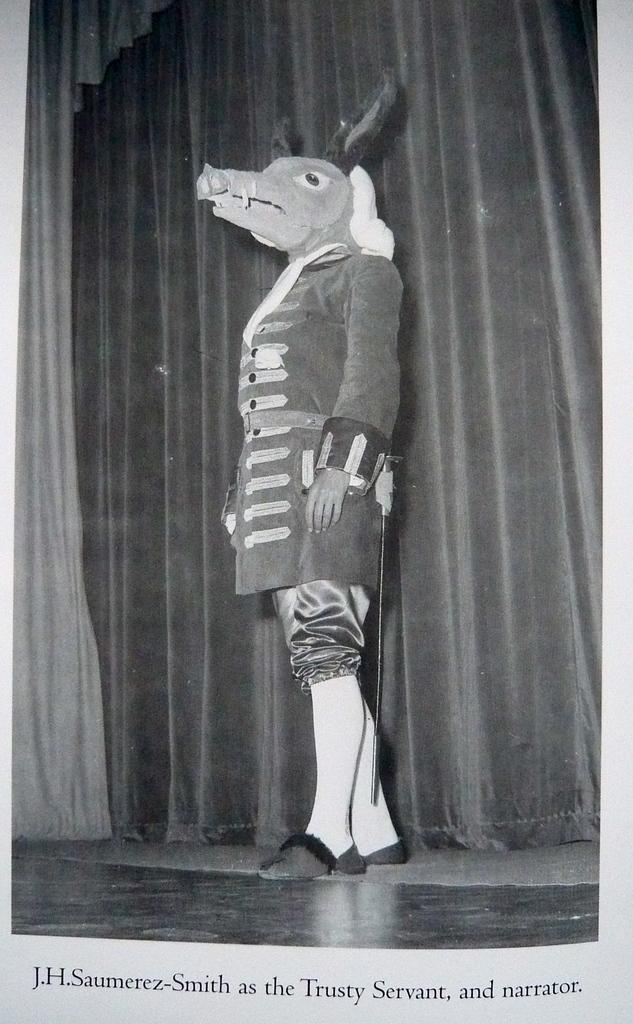What is the main setting of the image? The image depicts a stage. What is the person on the stage wearing? The person on the stage is wearing a mask of an animal. What can be seen in the background of the stage? There is a curtain in the background of the stage. What additional information is provided at the bottom of the image? There is text written at the bottom of the image. How is the image presented in terms of color? The image is in black and white. How many mice can be seen running across the railway in the image? There are no mice or railway present in the image; it depicts a stage with a person wearing an animal mask. What type of truck is parked near the stage in the image? There is no truck present in the image; it only shows a stage with a person wearing an animal mask and a curtain in the background. 